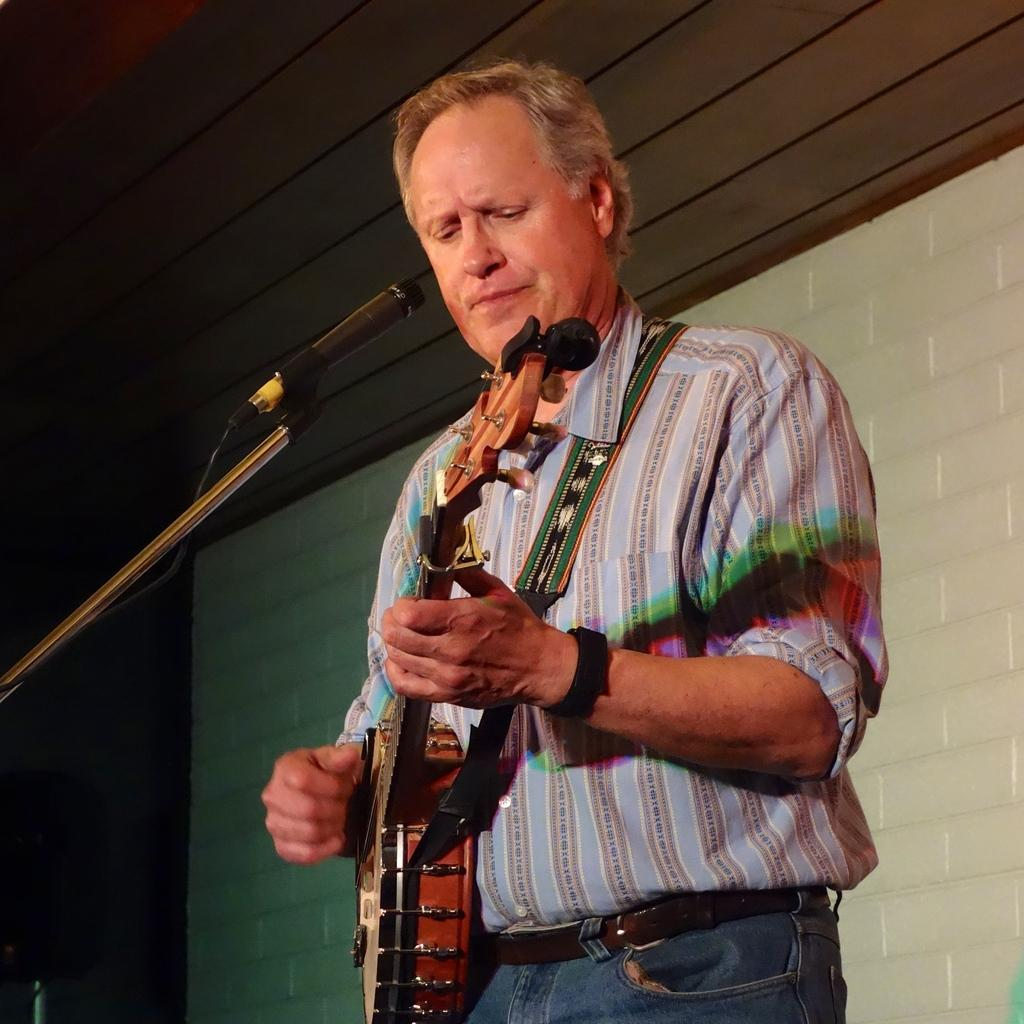Who is the main subject in the image? There is a man in the image. What is the man holding in the image? The man is holding a music instrument. What is in front of the man that might be used for amplifying his voice? There is a microphone with a stand in front of the man. What can be seen in the background of the image? The background of the image includes a white wall. What type of stamp can be seen on the man's forehead in the image? There is no stamp present on the man's forehead in the image. 